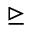<formula> <loc_0><loc_0><loc_500><loc_500>\triangleright e q</formula> 